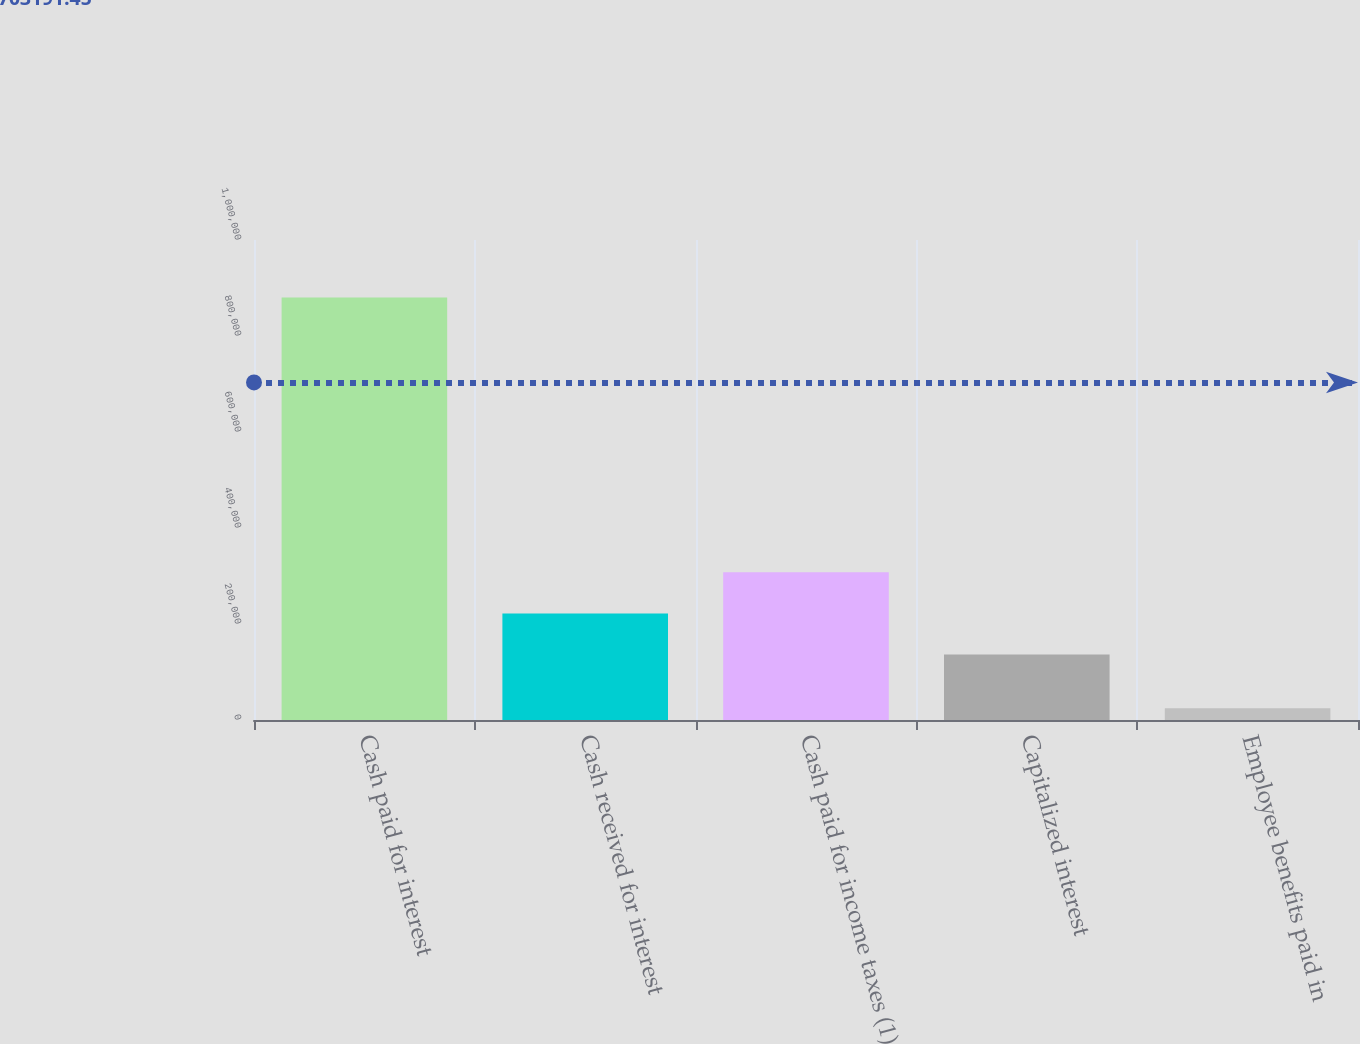Convert chart. <chart><loc_0><loc_0><loc_500><loc_500><bar_chart><fcel>Cash paid for interest<fcel>Cash received for interest<fcel>Cash paid for income taxes (1)<fcel>Capitalized interest<fcel>Employee benefits paid in<nl><fcel>880244<fcel>222109<fcel>307711<fcel>136508<fcel>24230<nl></chart> 